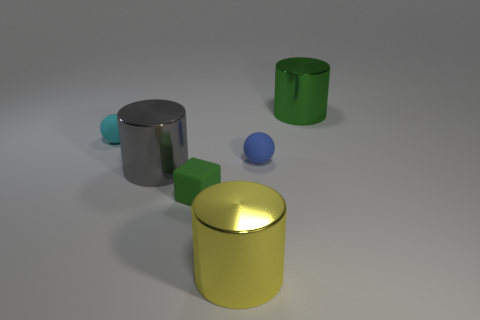Add 4 cylinders. How many objects exist? 10 Subtract all balls. How many objects are left? 4 Subtract all small green cubes. Subtract all tiny purple rubber things. How many objects are left? 5 Add 6 small things. How many small things are left? 9 Add 2 large yellow things. How many large yellow things exist? 3 Subtract 0 brown cylinders. How many objects are left? 6 